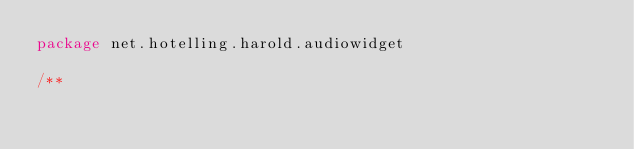<code> <loc_0><loc_0><loc_500><loc_500><_Scala_>package net.hotelling.harold.audiowidget

/**</code> 